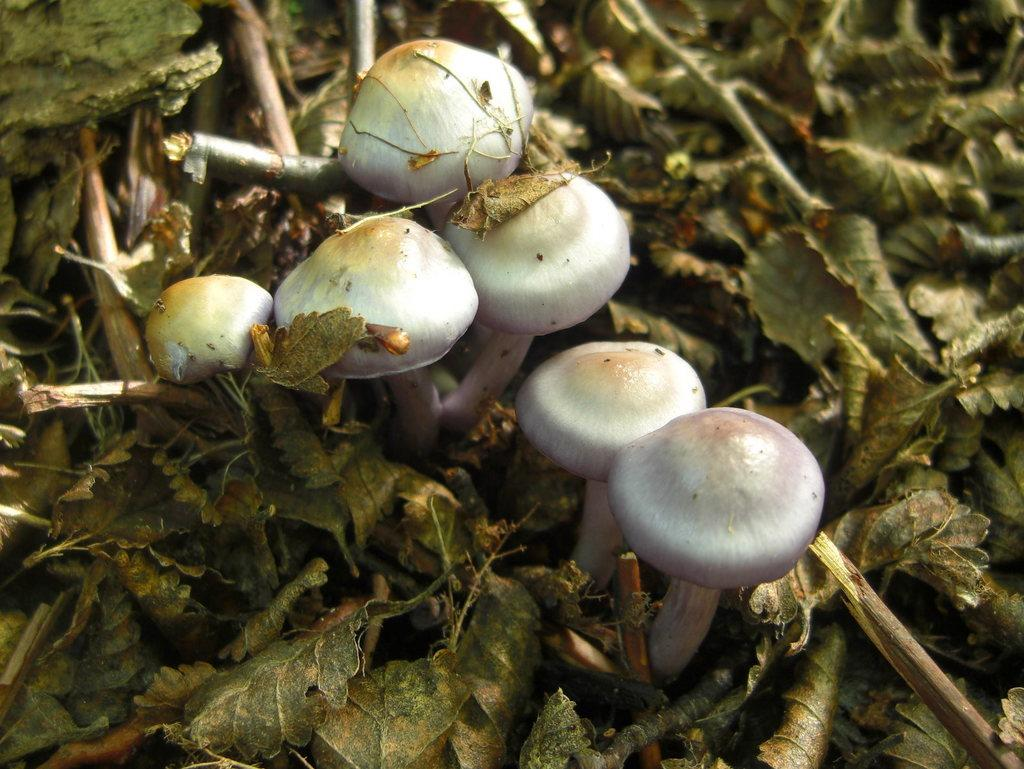What type of fungi can be seen in the image? There are mushrooms in the image. What type of plant material is present in the image? There are dried leaves in the image. Can you see a snail crawling on the mushrooms in the image? There is no snail present in the image; it only features mushrooms and dried leaves. What message of hope can be found in the image? The image does not convey any specific message or emotion, such as hope. 